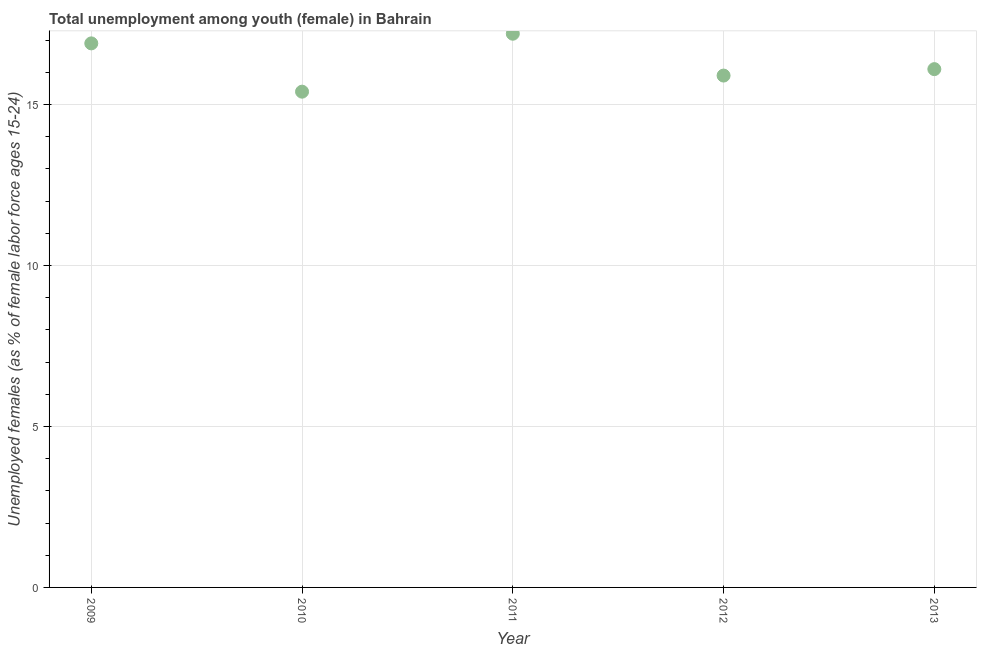What is the unemployed female youth population in 2011?
Make the answer very short. 17.2. Across all years, what is the maximum unemployed female youth population?
Your answer should be compact. 17.2. Across all years, what is the minimum unemployed female youth population?
Your answer should be very brief. 15.4. What is the sum of the unemployed female youth population?
Your answer should be very brief. 81.5. What is the difference between the unemployed female youth population in 2011 and 2013?
Give a very brief answer. 1.1. What is the average unemployed female youth population per year?
Make the answer very short. 16.3. What is the median unemployed female youth population?
Make the answer very short. 16.1. What is the ratio of the unemployed female youth population in 2009 to that in 2013?
Offer a very short reply. 1.05. What is the difference between the highest and the second highest unemployed female youth population?
Ensure brevity in your answer.  0.3. Is the sum of the unemployed female youth population in 2012 and 2013 greater than the maximum unemployed female youth population across all years?
Keep it short and to the point. Yes. What is the difference between the highest and the lowest unemployed female youth population?
Offer a terse response. 1.8. In how many years, is the unemployed female youth population greater than the average unemployed female youth population taken over all years?
Give a very brief answer. 2. Does the unemployed female youth population monotonically increase over the years?
Offer a terse response. No. Does the graph contain any zero values?
Offer a very short reply. No. Does the graph contain grids?
Keep it short and to the point. Yes. What is the title of the graph?
Provide a short and direct response. Total unemployment among youth (female) in Bahrain. What is the label or title of the X-axis?
Your response must be concise. Year. What is the label or title of the Y-axis?
Your response must be concise. Unemployed females (as % of female labor force ages 15-24). What is the Unemployed females (as % of female labor force ages 15-24) in 2009?
Keep it short and to the point. 16.9. What is the Unemployed females (as % of female labor force ages 15-24) in 2010?
Provide a succinct answer. 15.4. What is the Unemployed females (as % of female labor force ages 15-24) in 2011?
Keep it short and to the point. 17.2. What is the Unemployed females (as % of female labor force ages 15-24) in 2012?
Your answer should be very brief. 15.9. What is the Unemployed females (as % of female labor force ages 15-24) in 2013?
Offer a terse response. 16.1. What is the difference between the Unemployed females (as % of female labor force ages 15-24) in 2009 and 2013?
Your answer should be compact. 0.8. What is the difference between the Unemployed females (as % of female labor force ages 15-24) in 2010 and 2013?
Provide a short and direct response. -0.7. What is the difference between the Unemployed females (as % of female labor force ages 15-24) in 2011 and 2012?
Keep it short and to the point. 1.3. What is the ratio of the Unemployed females (as % of female labor force ages 15-24) in 2009 to that in 2010?
Provide a short and direct response. 1.1. What is the ratio of the Unemployed females (as % of female labor force ages 15-24) in 2009 to that in 2011?
Offer a terse response. 0.98. What is the ratio of the Unemployed females (as % of female labor force ages 15-24) in 2009 to that in 2012?
Offer a very short reply. 1.06. What is the ratio of the Unemployed females (as % of female labor force ages 15-24) in 2010 to that in 2011?
Offer a terse response. 0.9. What is the ratio of the Unemployed females (as % of female labor force ages 15-24) in 2010 to that in 2012?
Ensure brevity in your answer.  0.97. What is the ratio of the Unemployed females (as % of female labor force ages 15-24) in 2010 to that in 2013?
Make the answer very short. 0.96. What is the ratio of the Unemployed females (as % of female labor force ages 15-24) in 2011 to that in 2012?
Keep it short and to the point. 1.08. What is the ratio of the Unemployed females (as % of female labor force ages 15-24) in 2011 to that in 2013?
Your response must be concise. 1.07. What is the ratio of the Unemployed females (as % of female labor force ages 15-24) in 2012 to that in 2013?
Provide a short and direct response. 0.99. 